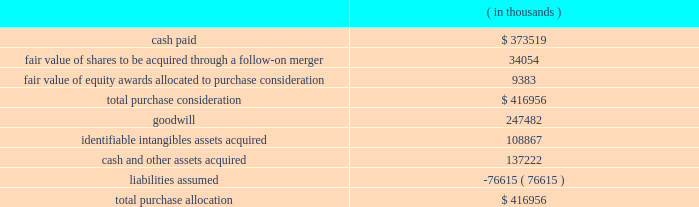Synopsys , inc .
Notes to consolidated financial statements 2014continued the aggregate purchase price consideration was approximately us$ 417.0 million .
As of october 31 , 2012 , the total purchase consideration and the preliminary purchase price allocation were as follows: .
Goodwill of $ 247.5 million , which is generally not deductible for tax purposes , primarily resulted from the company 2019s expectation of sales growth and cost synergies from the integration of springsoft 2019s technology and operations with the company 2019s technology and operations .
Identifiable intangible assets , consisting primarily of technology , customer relationships , backlog and trademarks , were valued using the income method , and are being amortized over three to eight years .
Acquisition-related costs directly attributable to the business combination were $ 6.6 million for fiscal 2012 and were expensed as incurred in the consolidated statements of operations .
These costs consisted primarily of employee separation costs and professional services .
Fair value of equity awards : pursuant to the merger agreement , the company assumed all the unvested outstanding stock options of springsoft upon the completion of the merger and the vested options were exchanged for cash in the merger .
On october 1 , 2012 , the date of the completion of the tender offer , the fair value of the awards to be assumed and exchanged was $ 9.9 million , calculated using the black-scholes option pricing model .
The black-scholes option-pricing model incorporates various subjective assumptions including expected volatility , expected term and risk-free interest rates .
The expected volatility was estimated by a combination of implied and historical stock price volatility of the options .
Non-controlling interest : non-controlling interest represents the fair value of the 8.4% ( 8.4 % ) of outstanding springsoft shares that were not acquired during the tender offer process completed on october 1 , 2012 and the fair value of the option awards that were to be assumed or exchanged for cash upon the follow-on merger .
The fair value of the non-controlling interest included as part of the aggregate purchase consideration was $ 42.8 million and is disclosed as a separate line in the october 31 , 2012 consolidated statements of stockholders 2019 equity .
During the period between the completion of the tender offer and the end of the company 2019s fiscal year on october 31 , 2012 , the non-controlling interest was adjusted by $ 0.5 million to reflect the non-controlling interest 2019s share of the operating loss of springsoft in that period .
As the amount is not significant , it has been included as part of other income ( expense ) , net , in the consolidated statements of operations. .
What percentage of total purchase allocation is identifiable intangibles assets acquired? 
Computations: (108867 / 416956)
Answer: 0.2611. 